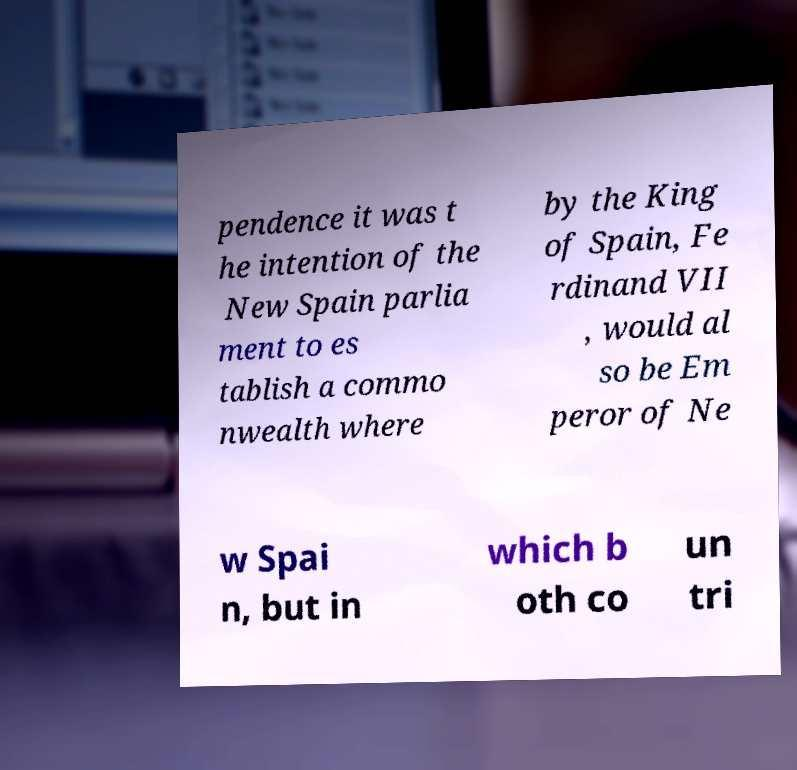What messages or text are displayed in this image? I need them in a readable, typed format. pendence it was t he intention of the New Spain parlia ment to es tablish a commo nwealth where by the King of Spain, Fe rdinand VII , would al so be Em peror of Ne w Spai n, but in which b oth co un tri 